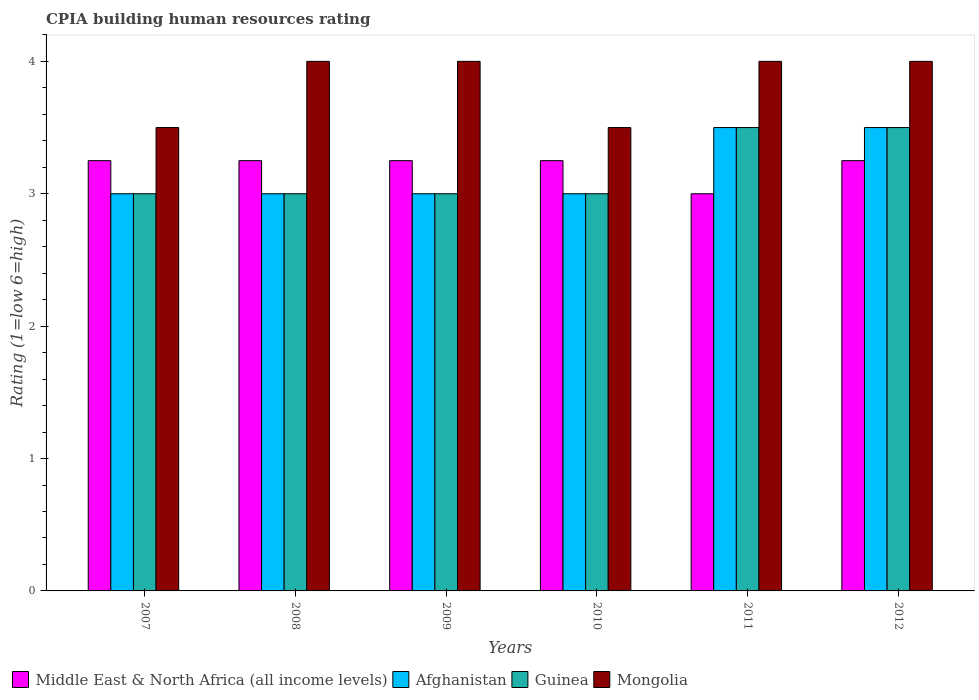How many different coloured bars are there?
Make the answer very short. 4. How many bars are there on the 3rd tick from the right?
Your answer should be very brief. 4. What is the label of the 2nd group of bars from the left?
Offer a terse response. 2008. In how many cases, is the number of bars for a given year not equal to the number of legend labels?
Offer a very short reply. 0. Across all years, what is the maximum CPIA rating in Mongolia?
Keep it short and to the point. 4. In which year was the CPIA rating in Mongolia minimum?
Offer a terse response. 2007. What is the average CPIA rating in Mongolia per year?
Your answer should be compact. 3.83. In how many years, is the CPIA rating in Guinea greater than 1.2?
Ensure brevity in your answer.  6. What is the ratio of the CPIA rating in Mongolia in 2010 to that in 2011?
Make the answer very short. 0.88. Is the CPIA rating in Guinea in 2008 less than that in 2011?
Your answer should be compact. Yes. What is the difference between the highest and the second highest CPIA rating in Guinea?
Provide a short and direct response. 0. In how many years, is the CPIA rating in Mongolia greater than the average CPIA rating in Mongolia taken over all years?
Provide a succinct answer. 4. Is the sum of the CPIA rating in Afghanistan in 2009 and 2011 greater than the maximum CPIA rating in Mongolia across all years?
Your answer should be compact. Yes. Is it the case that in every year, the sum of the CPIA rating in Mongolia and CPIA rating in Guinea is greater than the sum of CPIA rating in Afghanistan and CPIA rating in Middle East & North Africa (all income levels)?
Keep it short and to the point. No. What does the 2nd bar from the left in 2008 represents?
Provide a succinct answer. Afghanistan. What does the 4th bar from the right in 2010 represents?
Give a very brief answer. Middle East & North Africa (all income levels). How many bars are there?
Your response must be concise. 24. What is the difference between two consecutive major ticks on the Y-axis?
Offer a terse response. 1. Are the values on the major ticks of Y-axis written in scientific E-notation?
Offer a terse response. No. How many legend labels are there?
Ensure brevity in your answer.  4. How are the legend labels stacked?
Your answer should be compact. Horizontal. What is the title of the graph?
Your answer should be very brief. CPIA building human resources rating. What is the label or title of the X-axis?
Provide a succinct answer. Years. What is the Rating (1=low 6=high) of Middle East & North Africa (all income levels) in 2007?
Keep it short and to the point. 3.25. What is the Rating (1=low 6=high) of Mongolia in 2007?
Make the answer very short. 3.5. What is the Rating (1=low 6=high) of Middle East & North Africa (all income levels) in 2008?
Offer a terse response. 3.25. What is the Rating (1=low 6=high) in Afghanistan in 2009?
Ensure brevity in your answer.  3. What is the Rating (1=low 6=high) of Mongolia in 2009?
Your response must be concise. 4. What is the Rating (1=low 6=high) of Middle East & North Africa (all income levels) in 2010?
Provide a short and direct response. 3.25. What is the Rating (1=low 6=high) of Afghanistan in 2010?
Make the answer very short. 3. What is the Rating (1=low 6=high) in Afghanistan in 2011?
Offer a very short reply. 3.5. What is the Rating (1=low 6=high) in Guinea in 2011?
Your answer should be very brief. 3.5. What is the Rating (1=low 6=high) of Mongolia in 2011?
Your response must be concise. 4. What is the Rating (1=low 6=high) of Middle East & North Africa (all income levels) in 2012?
Your answer should be compact. 3.25. What is the Rating (1=low 6=high) in Afghanistan in 2012?
Provide a short and direct response. 3.5. What is the Rating (1=low 6=high) in Guinea in 2012?
Keep it short and to the point. 3.5. What is the Rating (1=low 6=high) in Mongolia in 2012?
Provide a succinct answer. 4. Across all years, what is the maximum Rating (1=low 6=high) in Middle East & North Africa (all income levels)?
Provide a short and direct response. 3.25. Across all years, what is the maximum Rating (1=low 6=high) of Afghanistan?
Offer a very short reply. 3.5. Across all years, what is the maximum Rating (1=low 6=high) of Guinea?
Your response must be concise. 3.5. Across all years, what is the maximum Rating (1=low 6=high) in Mongolia?
Offer a terse response. 4. Across all years, what is the minimum Rating (1=low 6=high) of Guinea?
Make the answer very short. 3. Across all years, what is the minimum Rating (1=low 6=high) of Mongolia?
Ensure brevity in your answer.  3.5. What is the total Rating (1=low 6=high) of Middle East & North Africa (all income levels) in the graph?
Your answer should be very brief. 19.25. What is the total Rating (1=low 6=high) in Afghanistan in the graph?
Offer a very short reply. 19. What is the total Rating (1=low 6=high) in Guinea in the graph?
Offer a terse response. 19. What is the total Rating (1=low 6=high) in Mongolia in the graph?
Provide a succinct answer. 23. What is the difference between the Rating (1=low 6=high) of Middle East & North Africa (all income levels) in 2007 and that in 2009?
Offer a terse response. 0. What is the difference between the Rating (1=low 6=high) in Afghanistan in 2007 and that in 2009?
Provide a succinct answer. 0. What is the difference between the Rating (1=low 6=high) in Mongolia in 2007 and that in 2009?
Provide a succinct answer. -0.5. What is the difference between the Rating (1=low 6=high) in Middle East & North Africa (all income levels) in 2007 and that in 2010?
Ensure brevity in your answer.  0. What is the difference between the Rating (1=low 6=high) of Afghanistan in 2007 and that in 2010?
Give a very brief answer. 0. What is the difference between the Rating (1=low 6=high) in Mongolia in 2007 and that in 2010?
Ensure brevity in your answer.  0. What is the difference between the Rating (1=low 6=high) of Afghanistan in 2007 and that in 2011?
Your answer should be very brief. -0.5. What is the difference between the Rating (1=low 6=high) in Middle East & North Africa (all income levels) in 2007 and that in 2012?
Keep it short and to the point. 0. What is the difference between the Rating (1=low 6=high) of Afghanistan in 2007 and that in 2012?
Offer a terse response. -0.5. What is the difference between the Rating (1=low 6=high) in Mongolia in 2007 and that in 2012?
Your answer should be very brief. -0.5. What is the difference between the Rating (1=low 6=high) of Guinea in 2008 and that in 2009?
Your response must be concise. 0. What is the difference between the Rating (1=low 6=high) in Afghanistan in 2008 and that in 2010?
Make the answer very short. 0. What is the difference between the Rating (1=low 6=high) in Guinea in 2008 and that in 2010?
Provide a succinct answer. 0. What is the difference between the Rating (1=low 6=high) in Mongolia in 2008 and that in 2010?
Ensure brevity in your answer.  0.5. What is the difference between the Rating (1=low 6=high) of Middle East & North Africa (all income levels) in 2008 and that in 2011?
Your response must be concise. 0.25. What is the difference between the Rating (1=low 6=high) in Guinea in 2008 and that in 2011?
Ensure brevity in your answer.  -0.5. What is the difference between the Rating (1=low 6=high) of Middle East & North Africa (all income levels) in 2008 and that in 2012?
Make the answer very short. 0. What is the difference between the Rating (1=low 6=high) in Afghanistan in 2008 and that in 2012?
Provide a succinct answer. -0.5. What is the difference between the Rating (1=low 6=high) in Guinea in 2008 and that in 2012?
Provide a short and direct response. -0.5. What is the difference between the Rating (1=low 6=high) in Mongolia in 2008 and that in 2012?
Keep it short and to the point. 0. What is the difference between the Rating (1=low 6=high) in Guinea in 2009 and that in 2010?
Give a very brief answer. 0. What is the difference between the Rating (1=low 6=high) in Mongolia in 2009 and that in 2010?
Provide a succinct answer. 0.5. What is the difference between the Rating (1=low 6=high) of Afghanistan in 2009 and that in 2011?
Offer a very short reply. -0.5. What is the difference between the Rating (1=low 6=high) of Guinea in 2009 and that in 2011?
Provide a short and direct response. -0.5. What is the difference between the Rating (1=low 6=high) in Mongolia in 2009 and that in 2011?
Your answer should be very brief. 0. What is the difference between the Rating (1=low 6=high) of Afghanistan in 2009 and that in 2012?
Give a very brief answer. -0.5. What is the difference between the Rating (1=low 6=high) in Mongolia in 2009 and that in 2012?
Your answer should be very brief. 0. What is the difference between the Rating (1=low 6=high) of Middle East & North Africa (all income levels) in 2010 and that in 2011?
Your answer should be compact. 0.25. What is the difference between the Rating (1=low 6=high) in Afghanistan in 2010 and that in 2011?
Provide a succinct answer. -0.5. What is the difference between the Rating (1=low 6=high) of Guinea in 2010 and that in 2011?
Ensure brevity in your answer.  -0.5. What is the difference between the Rating (1=low 6=high) in Mongolia in 2010 and that in 2011?
Give a very brief answer. -0.5. What is the difference between the Rating (1=low 6=high) in Middle East & North Africa (all income levels) in 2010 and that in 2012?
Offer a very short reply. 0. What is the difference between the Rating (1=low 6=high) in Guinea in 2010 and that in 2012?
Your answer should be compact. -0.5. What is the difference between the Rating (1=low 6=high) in Mongolia in 2010 and that in 2012?
Your response must be concise. -0.5. What is the difference between the Rating (1=low 6=high) in Middle East & North Africa (all income levels) in 2011 and that in 2012?
Your answer should be compact. -0.25. What is the difference between the Rating (1=low 6=high) of Afghanistan in 2011 and that in 2012?
Provide a short and direct response. 0. What is the difference between the Rating (1=low 6=high) in Guinea in 2011 and that in 2012?
Your answer should be very brief. 0. What is the difference between the Rating (1=low 6=high) of Mongolia in 2011 and that in 2012?
Your response must be concise. 0. What is the difference between the Rating (1=low 6=high) of Middle East & North Africa (all income levels) in 2007 and the Rating (1=low 6=high) of Afghanistan in 2008?
Make the answer very short. 0.25. What is the difference between the Rating (1=low 6=high) in Middle East & North Africa (all income levels) in 2007 and the Rating (1=low 6=high) in Mongolia in 2008?
Offer a terse response. -0.75. What is the difference between the Rating (1=low 6=high) in Afghanistan in 2007 and the Rating (1=low 6=high) in Guinea in 2008?
Offer a very short reply. 0. What is the difference between the Rating (1=low 6=high) in Guinea in 2007 and the Rating (1=low 6=high) in Mongolia in 2008?
Provide a short and direct response. -1. What is the difference between the Rating (1=low 6=high) in Middle East & North Africa (all income levels) in 2007 and the Rating (1=low 6=high) in Afghanistan in 2009?
Ensure brevity in your answer.  0.25. What is the difference between the Rating (1=low 6=high) of Middle East & North Africa (all income levels) in 2007 and the Rating (1=low 6=high) of Mongolia in 2009?
Make the answer very short. -0.75. What is the difference between the Rating (1=low 6=high) in Afghanistan in 2007 and the Rating (1=low 6=high) in Guinea in 2009?
Give a very brief answer. 0. What is the difference between the Rating (1=low 6=high) in Afghanistan in 2007 and the Rating (1=low 6=high) in Mongolia in 2009?
Keep it short and to the point. -1. What is the difference between the Rating (1=low 6=high) in Guinea in 2007 and the Rating (1=low 6=high) in Mongolia in 2009?
Make the answer very short. -1. What is the difference between the Rating (1=low 6=high) of Middle East & North Africa (all income levels) in 2007 and the Rating (1=low 6=high) of Afghanistan in 2010?
Your answer should be compact. 0.25. What is the difference between the Rating (1=low 6=high) in Middle East & North Africa (all income levels) in 2007 and the Rating (1=low 6=high) in Guinea in 2010?
Keep it short and to the point. 0.25. What is the difference between the Rating (1=low 6=high) in Afghanistan in 2007 and the Rating (1=low 6=high) in Mongolia in 2010?
Provide a short and direct response. -0.5. What is the difference between the Rating (1=low 6=high) in Middle East & North Africa (all income levels) in 2007 and the Rating (1=low 6=high) in Afghanistan in 2011?
Your answer should be compact. -0.25. What is the difference between the Rating (1=low 6=high) in Middle East & North Africa (all income levels) in 2007 and the Rating (1=low 6=high) in Guinea in 2011?
Make the answer very short. -0.25. What is the difference between the Rating (1=low 6=high) in Middle East & North Africa (all income levels) in 2007 and the Rating (1=low 6=high) in Mongolia in 2011?
Give a very brief answer. -0.75. What is the difference between the Rating (1=low 6=high) of Afghanistan in 2007 and the Rating (1=low 6=high) of Guinea in 2011?
Your response must be concise. -0.5. What is the difference between the Rating (1=low 6=high) of Afghanistan in 2007 and the Rating (1=low 6=high) of Mongolia in 2011?
Offer a very short reply. -1. What is the difference between the Rating (1=low 6=high) of Middle East & North Africa (all income levels) in 2007 and the Rating (1=low 6=high) of Guinea in 2012?
Provide a short and direct response. -0.25. What is the difference between the Rating (1=low 6=high) of Middle East & North Africa (all income levels) in 2007 and the Rating (1=low 6=high) of Mongolia in 2012?
Keep it short and to the point. -0.75. What is the difference between the Rating (1=low 6=high) of Afghanistan in 2007 and the Rating (1=low 6=high) of Guinea in 2012?
Give a very brief answer. -0.5. What is the difference between the Rating (1=low 6=high) in Middle East & North Africa (all income levels) in 2008 and the Rating (1=low 6=high) in Afghanistan in 2009?
Give a very brief answer. 0.25. What is the difference between the Rating (1=low 6=high) in Middle East & North Africa (all income levels) in 2008 and the Rating (1=low 6=high) in Mongolia in 2009?
Provide a succinct answer. -0.75. What is the difference between the Rating (1=low 6=high) of Afghanistan in 2008 and the Rating (1=low 6=high) of Guinea in 2009?
Your answer should be compact. 0. What is the difference between the Rating (1=low 6=high) of Afghanistan in 2008 and the Rating (1=low 6=high) of Mongolia in 2009?
Offer a very short reply. -1. What is the difference between the Rating (1=low 6=high) of Middle East & North Africa (all income levels) in 2008 and the Rating (1=low 6=high) of Guinea in 2010?
Offer a very short reply. 0.25. What is the difference between the Rating (1=low 6=high) of Middle East & North Africa (all income levels) in 2008 and the Rating (1=low 6=high) of Mongolia in 2010?
Provide a short and direct response. -0.25. What is the difference between the Rating (1=low 6=high) in Afghanistan in 2008 and the Rating (1=low 6=high) in Guinea in 2010?
Provide a short and direct response. 0. What is the difference between the Rating (1=low 6=high) in Afghanistan in 2008 and the Rating (1=low 6=high) in Mongolia in 2010?
Give a very brief answer. -0.5. What is the difference between the Rating (1=low 6=high) in Guinea in 2008 and the Rating (1=low 6=high) in Mongolia in 2010?
Your response must be concise. -0.5. What is the difference between the Rating (1=low 6=high) of Middle East & North Africa (all income levels) in 2008 and the Rating (1=low 6=high) of Afghanistan in 2011?
Keep it short and to the point. -0.25. What is the difference between the Rating (1=low 6=high) of Middle East & North Africa (all income levels) in 2008 and the Rating (1=low 6=high) of Guinea in 2011?
Ensure brevity in your answer.  -0.25. What is the difference between the Rating (1=low 6=high) of Middle East & North Africa (all income levels) in 2008 and the Rating (1=low 6=high) of Mongolia in 2011?
Your response must be concise. -0.75. What is the difference between the Rating (1=low 6=high) in Afghanistan in 2008 and the Rating (1=low 6=high) in Guinea in 2011?
Provide a succinct answer. -0.5. What is the difference between the Rating (1=low 6=high) of Afghanistan in 2008 and the Rating (1=low 6=high) of Mongolia in 2011?
Give a very brief answer. -1. What is the difference between the Rating (1=low 6=high) of Guinea in 2008 and the Rating (1=low 6=high) of Mongolia in 2011?
Your response must be concise. -1. What is the difference between the Rating (1=low 6=high) of Middle East & North Africa (all income levels) in 2008 and the Rating (1=low 6=high) of Afghanistan in 2012?
Keep it short and to the point. -0.25. What is the difference between the Rating (1=low 6=high) of Middle East & North Africa (all income levels) in 2008 and the Rating (1=low 6=high) of Guinea in 2012?
Offer a very short reply. -0.25. What is the difference between the Rating (1=low 6=high) of Middle East & North Africa (all income levels) in 2008 and the Rating (1=low 6=high) of Mongolia in 2012?
Your answer should be very brief. -0.75. What is the difference between the Rating (1=low 6=high) of Afghanistan in 2008 and the Rating (1=low 6=high) of Mongolia in 2012?
Make the answer very short. -1. What is the difference between the Rating (1=low 6=high) in Guinea in 2008 and the Rating (1=low 6=high) in Mongolia in 2012?
Keep it short and to the point. -1. What is the difference between the Rating (1=low 6=high) in Middle East & North Africa (all income levels) in 2009 and the Rating (1=low 6=high) in Afghanistan in 2010?
Your answer should be compact. 0.25. What is the difference between the Rating (1=low 6=high) in Middle East & North Africa (all income levels) in 2009 and the Rating (1=low 6=high) in Guinea in 2010?
Keep it short and to the point. 0.25. What is the difference between the Rating (1=low 6=high) in Middle East & North Africa (all income levels) in 2009 and the Rating (1=low 6=high) in Mongolia in 2010?
Your answer should be compact. -0.25. What is the difference between the Rating (1=low 6=high) in Afghanistan in 2009 and the Rating (1=low 6=high) in Mongolia in 2010?
Offer a terse response. -0.5. What is the difference between the Rating (1=low 6=high) of Middle East & North Africa (all income levels) in 2009 and the Rating (1=low 6=high) of Mongolia in 2011?
Ensure brevity in your answer.  -0.75. What is the difference between the Rating (1=low 6=high) of Middle East & North Africa (all income levels) in 2009 and the Rating (1=low 6=high) of Guinea in 2012?
Provide a succinct answer. -0.25. What is the difference between the Rating (1=low 6=high) in Middle East & North Africa (all income levels) in 2009 and the Rating (1=low 6=high) in Mongolia in 2012?
Offer a very short reply. -0.75. What is the difference between the Rating (1=low 6=high) of Guinea in 2009 and the Rating (1=low 6=high) of Mongolia in 2012?
Your answer should be very brief. -1. What is the difference between the Rating (1=low 6=high) of Middle East & North Africa (all income levels) in 2010 and the Rating (1=low 6=high) of Guinea in 2011?
Ensure brevity in your answer.  -0.25. What is the difference between the Rating (1=low 6=high) of Middle East & North Africa (all income levels) in 2010 and the Rating (1=low 6=high) of Mongolia in 2011?
Your answer should be very brief. -0.75. What is the difference between the Rating (1=low 6=high) in Afghanistan in 2010 and the Rating (1=low 6=high) in Guinea in 2011?
Provide a succinct answer. -0.5. What is the difference between the Rating (1=low 6=high) of Guinea in 2010 and the Rating (1=low 6=high) of Mongolia in 2011?
Make the answer very short. -1. What is the difference between the Rating (1=low 6=high) of Middle East & North Africa (all income levels) in 2010 and the Rating (1=low 6=high) of Mongolia in 2012?
Your answer should be very brief. -0.75. What is the difference between the Rating (1=low 6=high) of Afghanistan in 2010 and the Rating (1=low 6=high) of Mongolia in 2012?
Provide a succinct answer. -1. What is the difference between the Rating (1=low 6=high) of Middle East & North Africa (all income levels) in 2011 and the Rating (1=low 6=high) of Guinea in 2012?
Give a very brief answer. -0.5. What is the difference between the Rating (1=low 6=high) of Afghanistan in 2011 and the Rating (1=low 6=high) of Guinea in 2012?
Provide a succinct answer. 0. What is the average Rating (1=low 6=high) in Middle East & North Africa (all income levels) per year?
Give a very brief answer. 3.21. What is the average Rating (1=low 6=high) in Afghanistan per year?
Your answer should be compact. 3.17. What is the average Rating (1=low 6=high) in Guinea per year?
Your answer should be compact. 3.17. What is the average Rating (1=low 6=high) of Mongolia per year?
Provide a succinct answer. 3.83. In the year 2007, what is the difference between the Rating (1=low 6=high) of Middle East & North Africa (all income levels) and Rating (1=low 6=high) of Afghanistan?
Offer a very short reply. 0.25. In the year 2007, what is the difference between the Rating (1=low 6=high) of Middle East & North Africa (all income levels) and Rating (1=low 6=high) of Guinea?
Offer a very short reply. 0.25. In the year 2007, what is the difference between the Rating (1=low 6=high) of Middle East & North Africa (all income levels) and Rating (1=low 6=high) of Mongolia?
Offer a terse response. -0.25. In the year 2007, what is the difference between the Rating (1=low 6=high) of Afghanistan and Rating (1=low 6=high) of Guinea?
Provide a succinct answer. 0. In the year 2007, what is the difference between the Rating (1=low 6=high) in Afghanistan and Rating (1=low 6=high) in Mongolia?
Keep it short and to the point. -0.5. In the year 2007, what is the difference between the Rating (1=low 6=high) in Guinea and Rating (1=low 6=high) in Mongolia?
Offer a terse response. -0.5. In the year 2008, what is the difference between the Rating (1=low 6=high) of Middle East & North Africa (all income levels) and Rating (1=low 6=high) of Afghanistan?
Give a very brief answer. 0.25. In the year 2008, what is the difference between the Rating (1=low 6=high) in Middle East & North Africa (all income levels) and Rating (1=low 6=high) in Guinea?
Your answer should be very brief. 0.25. In the year 2008, what is the difference between the Rating (1=low 6=high) in Middle East & North Africa (all income levels) and Rating (1=low 6=high) in Mongolia?
Your response must be concise. -0.75. In the year 2008, what is the difference between the Rating (1=low 6=high) in Afghanistan and Rating (1=low 6=high) in Guinea?
Offer a terse response. 0. In the year 2008, what is the difference between the Rating (1=low 6=high) in Guinea and Rating (1=low 6=high) in Mongolia?
Offer a very short reply. -1. In the year 2009, what is the difference between the Rating (1=low 6=high) of Middle East & North Africa (all income levels) and Rating (1=low 6=high) of Afghanistan?
Your answer should be very brief. 0.25. In the year 2009, what is the difference between the Rating (1=low 6=high) in Middle East & North Africa (all income levels) and Rating (1=low 6=high) in Mongolia?
Provide a succinct answer. -0.75. In the year 2010, what is the difference between the Rating (1=low 6=high) of Middle East & North Africa (all income levels) and Rating (1=low 6=high) of Guinea?
Offer a terse response. 0.25. In the year 2010, what is the difference between the Rating (1=low 6=high) of Middle East & North Africa (all income levels) and Rating (1=low 6=high) of Mongolia?
Offer a very short reply. -0.25. In the year 2010, what is the difference between the Rating (1=low 6=high) in Afghanistan and Rating (1=low 6=high) in Guinea?
Make the answer very short. 0. In the year 2010, what is the difference between the Rating (1=low 6=high) of Afghanistan and Rating (1=low 6=high) of Mongolia?
Provide a short and direct response. -0.5. In the year 2010, what is the difference between the Rating (1=low 6=high) in Guinea and Rating (1=low 6=high) in Mongolia?
Ensure brevity in your answer.  -0.5. In the year 2011, what is the difference between the Rating (1=low 6=high) in Middle East & North Africa (all income levels) and Rating (1=low 6=high) in Afghanistan?
Offer a very short reply. -0.5. In the year 2011, what is the difference between the Rating (1=low 6=high) of Middle East & North Africa (all income levels) and Rating (1=low 6=high) of Guinea?
Provide a succinct answer. -0.5. In the year 2011, what is the difference between the Rating (1=low 6=high) of Middle East & North Africa (all income levels) and Rating (1=low 6=high) of Mongolia?
Your answer should be very brief. -1. In the year 2011, what is the difference between the Rating (1=low 6=high) in Afghanistan and Rating (1=low 6=high) in Mongolia?
Give a very brief answer. -0.5. In the year 2012, what is the difference between the Rating (1=low 6=high) in Middle East & North Africa (all income levels) and Rating (1=low 6=high) in Guinea?
Keep it short and to the point. -0.25. In the year 2012, what is the difference between the Rating (1=low 6=high) in Middle East & North Africa (all income levels) and Rating (1=low 6=high) in Mongolia?
Your response must be concise. -0.75. In the year 2012, what is the difference between the Rating (1=low 6=high) in Afghanistan and Rating (1=low 6=high) in Guinea?
Offer a terse response. 0. In the year 2012, what is the difference between the Rating (1=low 6=high) in Afghanistan and Rating (1=low 6=high) in Mongolia?
Offer a terse response. -0.5. In the year 2012, what is the difference between the Rating (1=low 6=high) in Guinea and Rating (1=low 6=high) in Mongolia?
Make the answer very short. -0.5. What is the ratio of the Rating (1=low 6=high) in Middle East & North Africa (all income levels) in 2007 to that in 2008?
Your answer should be very brief. 1. What is the ratio of the Rating (1=low 6=high) in Afghanistan in 2007 to that in 2008?
Offer a terse response. 1. What is the ratio of the Rating (1=low 6=high) in Mongolia in 2007 to that in 2008?
Provide a short and direct response. 0.88. What is the ratio of the Rating (1=low 6=high) in Afghanistan in 2007 to that in 2009?
Provide a succinct answer. 1. What is the ratio of the Rating (1=low 6=high) of Middle East & North Africa (all income levels) in 2007 to that in 2010?
Ensure brevity in your answer.  1. What is the ratio of the Rating (1=low 6=high) of Afghanistan in 2007 to that in 2011?
Ensure brevity in your answer.  0.86. What is the ratio of the Rating (1=low 6=high) of Guinea in 2007 to that in 2011?
Provide a succinct answer. 0.86. What is the ratio of the Rating (1=low 6=high) of Guinea in 2007 to that in 2012?
Offer a very short reply. 0.86. What is the ratio of the Rating (1=low 6=high) in Afghanistan in 2008 to that in 2009?
Keep it short and to the point. 1. What is the ratio of the Rating (1=low 6=high) in Afghanistan in 2008 to that in 2010?
Make the answer very short. 1. What is the ratio of the Rating (1=low 6=high) in Guinea in 2008 to that in 2010?
Your answer should be compact. 1. What is the ratio of the Rating (1=low 6=high) in Mongolia in 2008 to that in 2010?
Offer a very short reply. 1.14. What is the ratio of the Rating (1=low 6=high) of Middle East & North Africa (all income levels) in 2008 to that in 2011?
Make the answer very short. 1.08. What is the ratio of the Rating (1=low 6=high) in Guinea in 2008 to that in 2011?
Offer a terse response. 0.86. What is the ratio of the Rating (1=low 6=high) of Mongolia in 2008 to that in 2011?
Your response must be concise. 1. What is the ratio of the Rating (1=low 6=high) of Afghanistan in 2008 to that in 2012?
Give a very brief answer. 0.86. What is the ratio of the Rating (1=low 6=high) in Guinea in 2008 to that in 2012?
Ensure brevity in your answer.  0.86. What is the ratio of the Rating (1=low 6=high) of Mongolia in 2008 to that in 2012?
Give a very brief answer. 1. What is the ratio of the Rating (1=low 6=high) in Guinea in 2009 to that in 2010?
Your answer should be very brief. 1. What is the ratio of the Rating (1=low 6=high) of Guinea in 2009 to that in 2011?
Offer a terse response. 0.86. What is the ratio of the Rating (1=low 6=high) in Mongolia in 2009 to that in 2011?
Give a very brief answer. 1. What is the ratio of the Rating (1=low 6=high) of Guinea in 2009 to that in 2012?
Provide a succinct answer. 0.86. What is the ratio of the Rating (1=low 6=high) of Mongolia in 2009 to that in 2012?
Offer a very short reply. 1. What is the ratio of the Rating (1=low 6=high) in Middle East & North Africa (all income levels) in 2010 to that in 2011?
Provide a succinct answer. 1.08. What is the ratio of the Rating (1=low 6=high) in Mongolia in 2010 to that in 2011?
Offer a very short reply. 0.88. What is the ratio of the Rating (1=low 6=high) of Mongolia in 2010 to that in 2012?
Ensure brevity in your answer.  0.88. What is the ratio of the Rating (1=low 6=high) in Middle East & North Africa (all income levels) in 2011 to that in 2012?
Your response must be concise. 0.92. What is the ratio of the Rating (1=low 6=high) of Afghanistan in 2011 to that in 2012?
Keep it short and to the point. 1. What is the ratio of the Rating (1=low 6=high) in Mongolia in 2011 to that in 2012?
Ensure brevity in your answer.  1. What is the difference between the highest and the second highest Rating (1=low 6=high) of Middle East & North Africa (all income levels)?
Offer a terse response. 0. What is the difference between the highest and the second highest Rating (1=low 6=high) in Afghanistan?
Your answer should be very brief. 0. What is the difference between the highest and the second highest Rating (1=low 6=high) of Guinea?
Provide a succinct answer. 0. What is the difference between the highest and the second highest Rating (1=low 6=high) of Mongolia?
Your answer should be compact. 0. What is the difference between the highest and the lowest Rating (1=low 6=high) in Middle East & North Africa (all income levels)?
Make the answer very short. 0.25. 